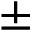<formula> <loc_0><loc_0><loc_500><loc_500>\pm</formula> 